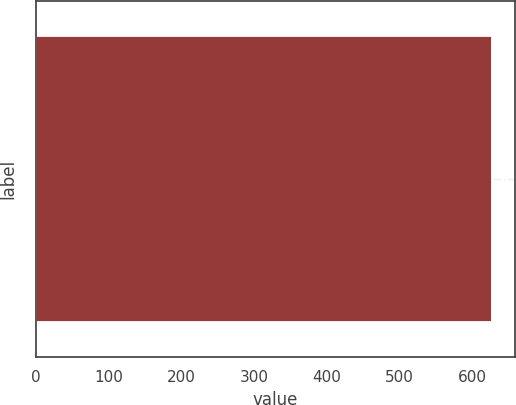Convert chart to OTSL. <chart><loc_0><loc_0><loc_500><loc_500><bar_chart><ecel><nl><fcel>627<nl></chart> 